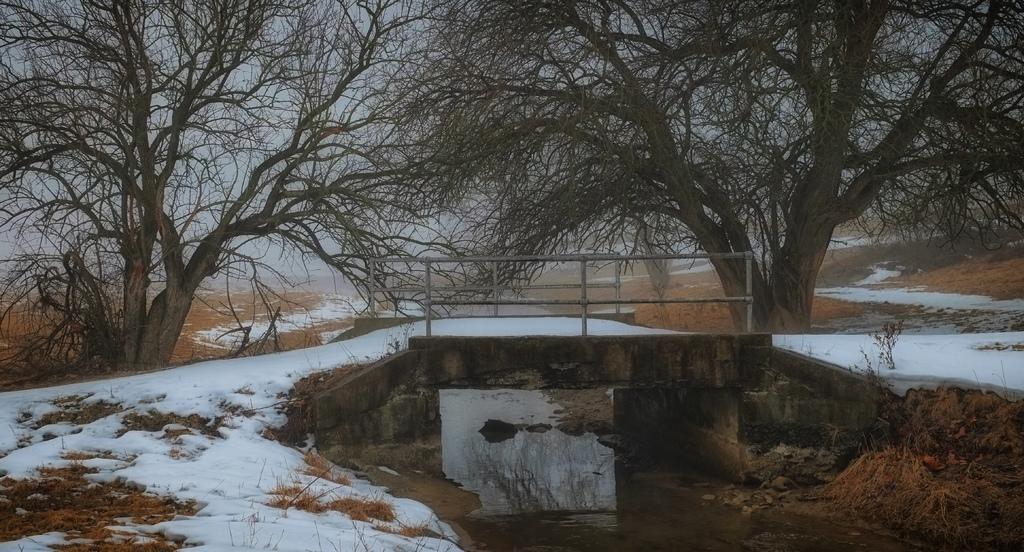Could you give a brief overview of what you see in this image? In this image there is snow, water, plants, bridge, trees , and in the background there is sky. 